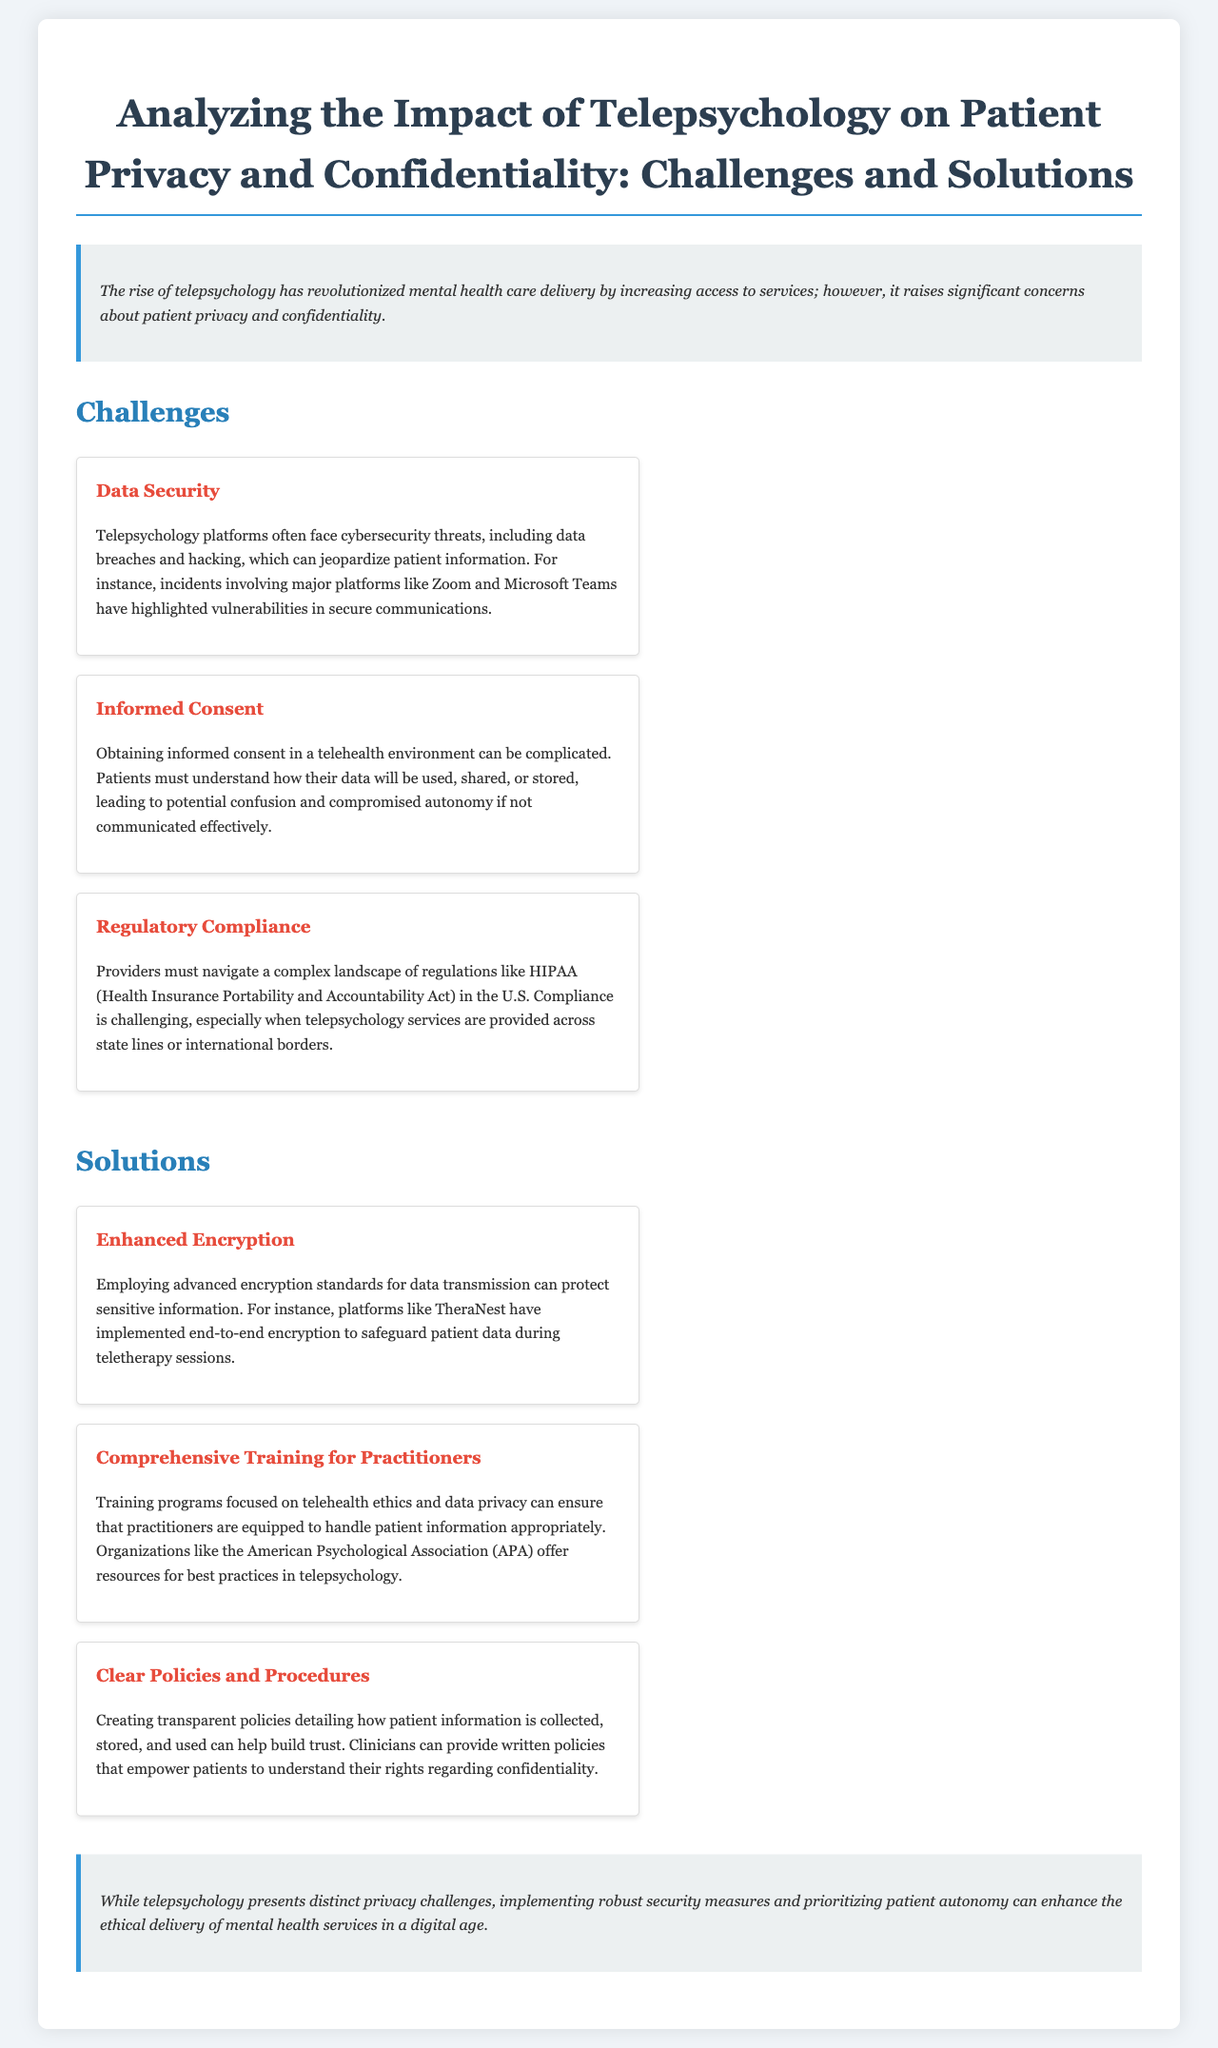What is the main concern regarding telepsychology? The document states that "it raises significant concerns about patient privacy and confidentiality."
Answer: patient privacy and confidentiality Which act governs regulatory compliance in telepsychology? The document mentions the "Health Insurance Portability and Accountability Act" as a key regulation.
Answer: HIPAA What is one major challenge associated with data security in telepsychology? The document highlights "cybersecurity threats, including data breaches and hacking" as a challenge.
Answer: data breaches and hacking What kind of encryption can protect sensitive information? The document refers to "advanced encryption standards" as a solution for data protection.
Answer: advanced encryption standards Which organization offers resources for best practices in telepsychology? The document states that "the American Psychological Association (APA)" provides resources for telepsychology practitioners.
Answer: American Psychological Association (APA) What is a recommended solution for enhancing patient trust? The document suggests "creating transparent policies detailing how patient information is collected, stored, and used" to build trust.
Answer: transparent policies How does telepsychology affect informed consent? The document notes that obtaining informed consent can become "complicated" in a telehealth environment.
Answer: complicated What type of training is recommended for practitioners? The document advocates for "training programs focused on telehealth ethics and data privacy."
Answer: telehealth ethics and data privacy What is a potential effect of refusing to address privacy challenges in telepsychology? The conclusion implies that ignoring these challenges could compromise "the ethical delivery of mental health services."
Answer: ethical delivery of mental health services 